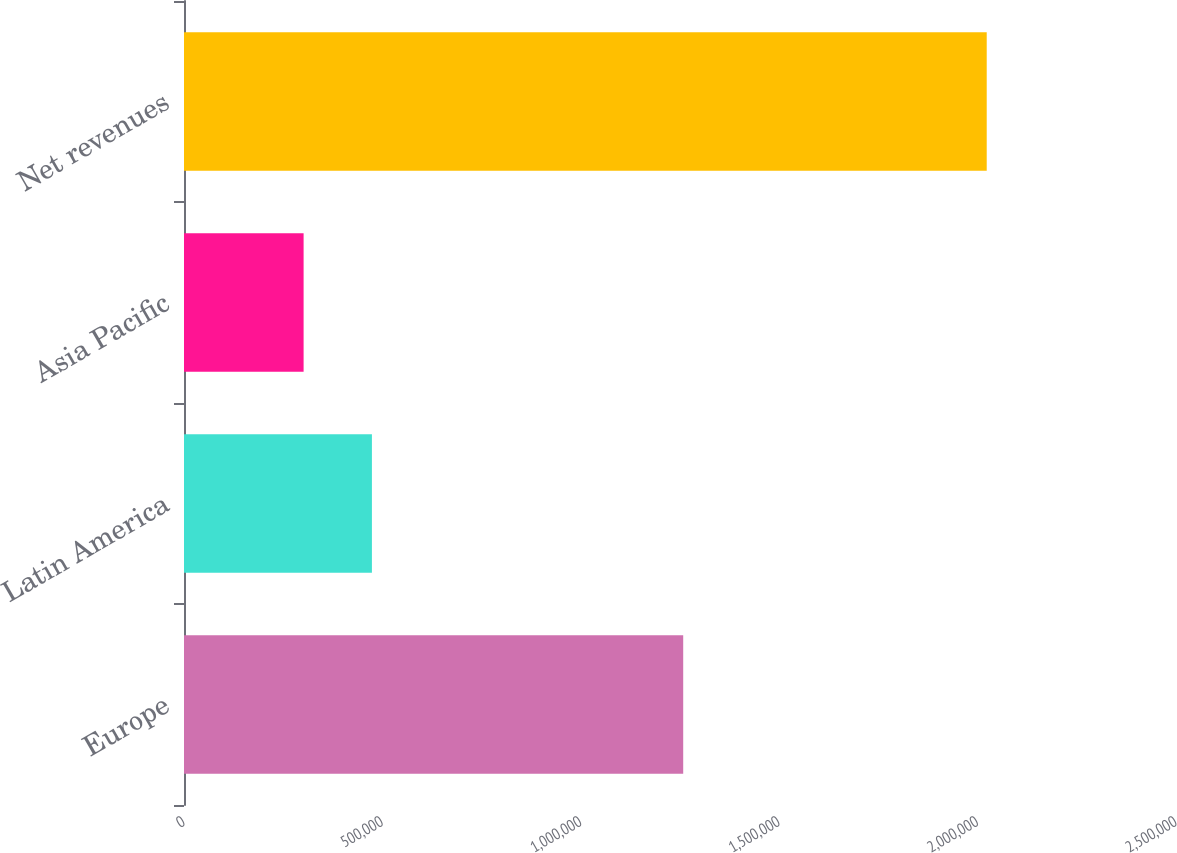Convert chart. <chart><loc_0><loc_0><loc_500><loc_500><bar_chart><fcel>Europe<fcel>Latin America<fcel>Asia Pacific<fcel>Net revenues<nl><fcel>1.25808e+06<fcel>473566<fcel>301407<fcel>2.023e+06<nl></chart> 